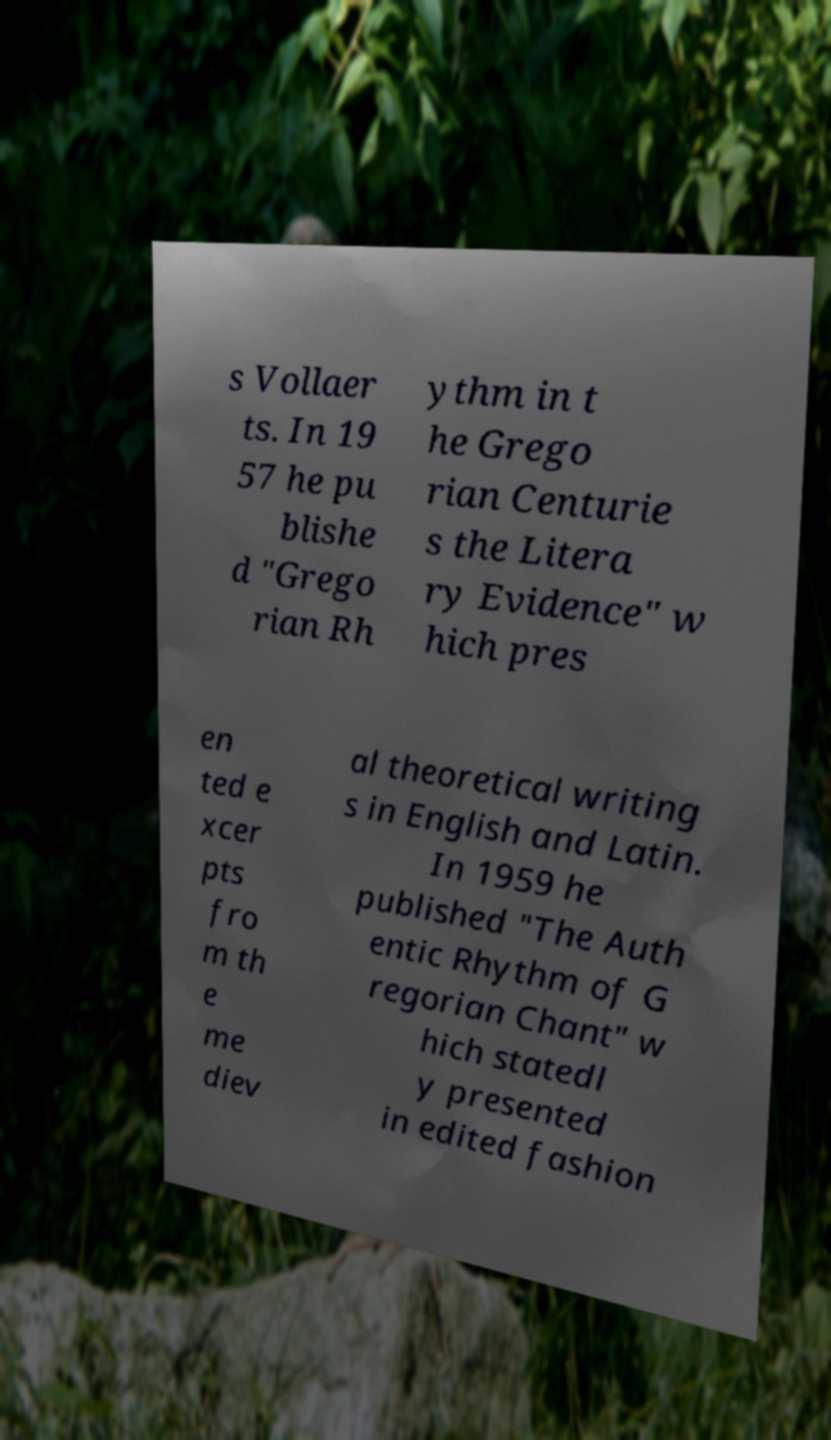For documentation purposes, I need the text within this image transcribed. Could you provide that? s Vollaer ts. In 19 57 he pu blishe d "Grego rian Rh ythm in t he Grego rian Centurie s the Litera ry Evidence" w hich pres en ted e xcer pts fro m th e me diev al theoretical writing s in English and Latin. In 1959 he published "The Auth entic Rhythm of G regorian Chant" w hich statedl y presented in edited fashion 